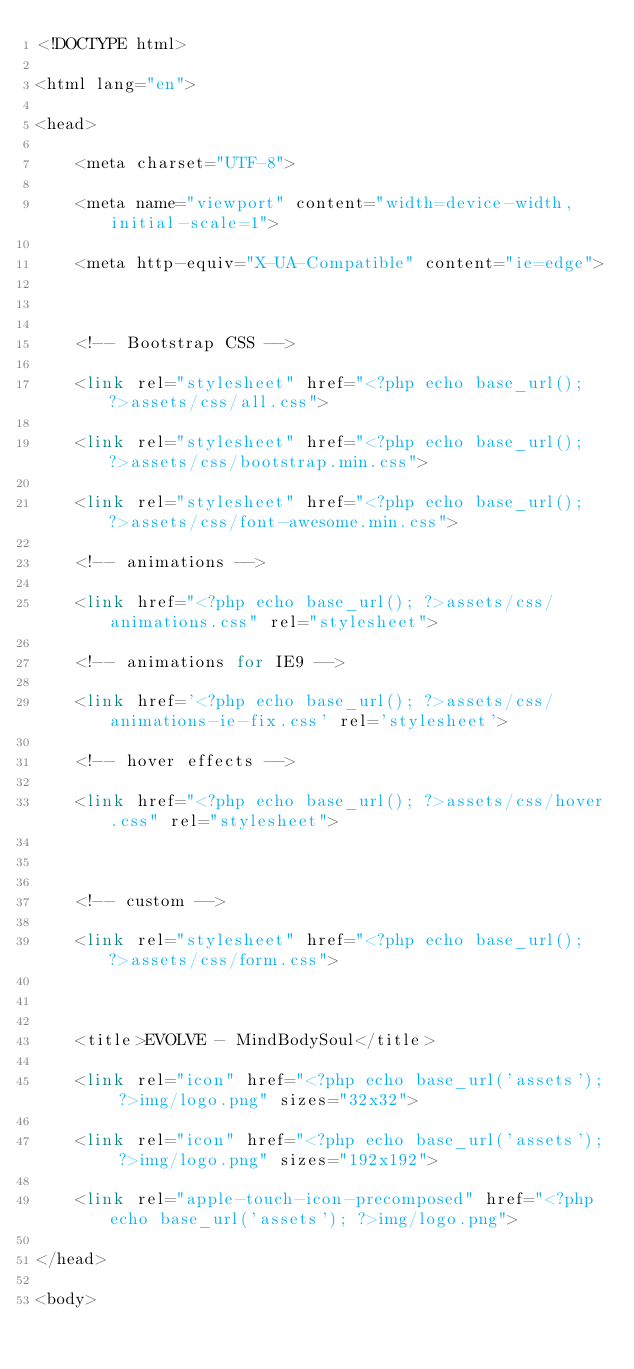Convert code to text. <code><loc_0><loc_0><loc_500><loc_500><_PHP_><!DOCTYPE html>

<html lang="en">

<head>

    <meta charset="UTF-8">

    <meta name="viewport" content="width=device-width, initial-scale=1">

    <meta http-equiv="X-UA-Compatible" content="ie=edge">



    <!-- Bootstrap CSS -->

    <link rel="stylesheet" href="<?php echo base_url(); ?>assets/css/all.css">

    <link rel="stylesheet" href="<?php echo base_url(); ?>assets/css/bootstrap.min.css">

    <link rel="stylesheet" href="<?php echo base_url(); ?>assets/css/font-awesome.min.css">

    <!-- animations -->

    <link href="<?php echo base_url(); ?>assets/css/animations.css" rel="stylesheet">

    <!-- animations for IE9 -->

    <link href='<?php echo base_url(); ?>assets/css/animations-ie-fix.css' rel='stylesheet'>

    <!-- hover effects -->

    <link href="<?php echo base_url(); ?>assets/css/hover.css" rel="stylesheet">



    <!-- custom -->

    <link rel="stylesheet" href="<?php echo base_url(); ?>assets/css/form.css">



    <title>EVOLVE - MindBodySoul</title>

    <link rel="icon" href="<?php echo base_url('assets'); ?>img/logo.png" sizes="32x32">

    <link rel="icon" href="<?php echo base_url('assets'); ?>img/logo.png" sizes="192x192">

    <link rel="apple-touch-icon-precomposed" href="<?php echo base_url('assets'); ?>img/logo.png">

</head>

<body></code> 